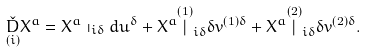Convert formula to latex. <formula><loc_0><loc_0><loc_500><loc_500>\underset { \left ( i \right ) } { \check { D } } X ^ { a } = X ^ { a } \shortmid _ { i \delta } d u ^ { \delta } + X ^ { a } \overset { \left ( 1 \right ) } { | } _ { i \delta } \delta v ^ { \left ( 1 \right ) \delta } + X ^ { a } \overset { \left ( 2 \right ) } { | } _ { i \delta } \delta v ^ { \left ( 2 \right ) \delta } .</formula> 